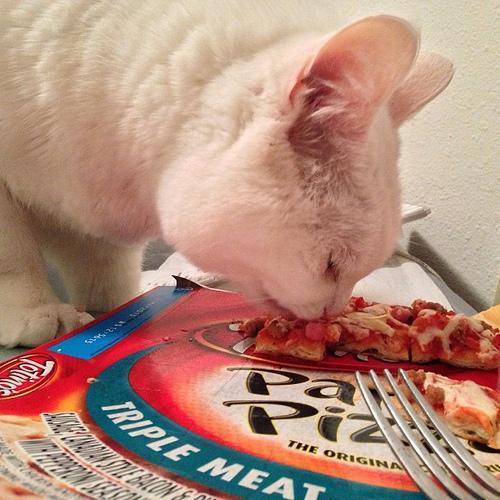How many cats are pictured?
Give a very brief answer. 1. How many cats are drinking water?
Give a very brief answer. 0. 